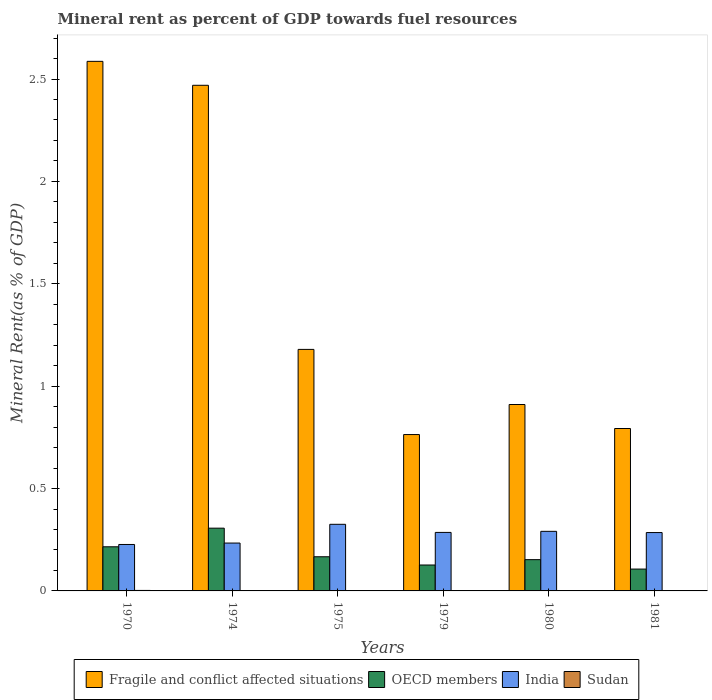How many groups of bars are there?
Make the answer very short. 6. How many bars are there on the 6th tick from the left?
Offer a very short reply. 4. How many bars are there on the 6th tick from the right?
Give a very brief answer. 4. What is the label of the 2nd group of bars from the left?
Offer a terse response. 1974. What is the mineral rent in OECD members in 1980?
Give a very brief answer. 0.15. Across all years, what is the maximum mineral rent in OECD members?
Offer a very short reply. 0.31. Across all years, what is the minimum mineral rent in India?
Keep it short and to the point. 0.23. In which year was the mineral rent in OECD members maximum?
Keep it short and to the point. 1974. In which year was the mineral rent in Sudan minimum?
Your answer should be very brief. 1975. What is the total mineral rent in OECD members in the graph?
Offer a terse response. 1.07. What is the difference between the mineral rent in Fragile and conflict affected situations in 1979 and that in 1981?
Your answer should be very brief. -0.03. What is the difference between the mineral rent in OECD members in 1981 and the mineral rent in Sudan in 1980?
Ensure brevity in your answer.  0.11. What is the average mineral rent in Fragile and conflict affected situations per year?
Make the answer very short. 1.45. In the year 1980, what is the difference between the mineral rent in OECD members and mineral rent in Sudan?
Give a very brief answer. 0.15. What is the ratio of the mineral rent in Fragile and conflict affected situations in 1974 to that in 1981?
Make the answer very short. 3.11. What is the difference between the highest and the second highest mineral rent in Sudan?
Your answer should be very brief. 0. What is the difference between the highest and the lowest mineral rent in Sudan?
Provide a succinct answer. 0. Is it the case that in every year, the sum of the mineral rent in Fragile and conflict affected situations and mineral rent in Sudan is greater than the mineral rent in OECD members?
Offer a terse response. Yes. How many years are there in the graph?
Your answer should be compact. 6. Does the graph contain grids?
Give a very brief answer. No. How many legend labels are there?
Provide a succinct answer. 4. What is the title of the graph?
Offer a terse response. Mineral rent as percent of GDP towards fuel resources. Does "Faeroe Islands" appear as one of the legend labels in the graph?
Your response must be concise. No. What is the label or title of the X-axis?
Offer a terse response. Years. What is the label or title of the Y-axis?
Keep it short and to the point. Mineral Rent(as % of GDP). What is the Mineral Rent(as % of GDP) of Fragile and conflict affected situations in 1970?
Provide a short and direct response. 2.59. What is the Mineral Rent(as % of GDP) in OECD members in 1970?
Provide a succinct answer. 0.22. What is the Mineral Rent(as % of GDP) in India in 1970?
Provide a succinct answer. 0.23. What is the Mineral Rent(as % of GDP) of Sudan in 1970?
Your answer should be very brief. 0. What is the Mineral Rent(as % of GDP) of Fragile and conflict affected situations in 1974?
Ensure brevity in your answer.  2.47. What is the Mineral Rent(as % of GDP) of OECD members in 1974?
Offer a very short reply. 0.31. What is the Mineral Rent(as % of GDP) in India in 1974?
Provide a short and direct response. 0.23. What is the Mineral Rent(as % of GDP) in Sudan in 1974?
Ensure brevity in your answer.  0. What is the Mineral Rent(as % of GDP) of Fragile and conflict affected situations in 1975?
Make the answer very short. 1.18. What is the Mineral Rent(as % of GDP) in OECD members in 1975?
Keep it short and to the point. 0.17. What is the Mineral Rent(as % of GDP) in India in 1975?
Offer a very short reply. 0.33. What is the Mineral Rent(as % of GDP) in Sudan in 1975?
Your answer should be very brief. 1.06889651710347e-5. What is the Mineral Rent(as % of GDP) of Fragile and conflict affected situations in 1979?
Your response must be concise. 0.76. What is the Mineral Rent(as % of GDP) in OECD members in 1979?
Keep it short and to the point. 0.13. What is the Mineral Rent(as % of GDP) in India in 1979?
Provide a succinct answer. 0.29. What is the Mineral Rent(as % of GDP) in Sudan in 1979?
Your response must be concise. 0. What is the Mineral Rent(as % of GDP) in Fragile and conflict affected situations in 1980?
Keep it short and to the point. 0.91. What is the Mineral Rent(as % of GDP) in OECD members in 1980?
Offer a very short reply. 0.15. What is the Mineral Rent(as % of GDP) of India in 1980?
Offer a terse response. 0.29. What is the Mineral Rent(as % of GDP) of Sudan in 1980?
Your answer should be very brief. 0. What is the Mineral Rent(as % of GDP) of Fragile and conflict affected situations in 1981?
Keep it short and to the point. 0.79. What is the Mineral Rent(as % of GDP) of OECD members in 1981?
Provide a short and direct response. 0.11. What is the Mineral Rent(as % of GDP) of India in 1981?
Make the answer very short. 0.29. What is the Mineral Rent(as % of GDP) in Sudan in 1981?
Offer a very short reply. 0. Across all years, what is the maximum Mineral Rent(as % of GDP) in Fragile and conflict affected situations?
Offer a very short reply. 2.59. Across all years, what is the maximum Mineral Rent(as % of GDP) of OECD members?
Give a very brief answer. 0.31. Across all years, what is the maximum Mineral Rent(as % of GDP) of India?
Your answer should be very brief. 0.33. Across all years, what is the maximum Mineral Rent(as % of GDP) of Sudan?
Your answer should be compact. 0. Across all years, what is the minimum Mineral Rent(as % of GDP) of Fragile and conflict affected situations?
Your answer should be compact. 0.76. Across all years, what is the minimum Mineral Rent(as % of GDP) in OECD members?
Offer a terse response. 0.11. Across all years, what is the minimum Mineral Rent(as % of GDP) in India?
Your answer should be very brief. 0.23. Across all years, what is the minimum Mineral Rent(as % of GDP) in Sudan?
Provide a short and direct response. 1.06889651710347e-5. What is the total Mineral Rent(as % of GDP) of Fragile and conflict affected situations in the graph?
Provide a short and direct response. 8.7. What is the total Mineral Rent(as % of GDP) of OECD members in the graph?
Your response must be concise. 1.07. What is the total Mineral Rent(as % of GDP) of India in the graph?
Ensure brevity in your answer.  1.65. What is the total Mineral Rent(as % of GDP) in Sudan in the graph?
Your answer should be very brief. 0. What is the difference between the Mineral Rent(as % of GDP) of Fragile and conflict affected situations in 1970 and that in 1974?
Give a very brief answer. 0.12. What is the difference between the Mineral Rent(as % of GDP) of OECD members in 1970 and that in 1974?
Your response must be concise. -0.09. What is the difference between the Mineral Rent(as % of GDP) in India in 1970 and that in 1974?
Offer a terse response. -0.01. What is the difference between the Mineral Rent(as % of GDP) of Sudan in 1970 and that in 1974?
Provide a succinct answer. 0. What is the difference between the Mineral Rent(as % of GDP) of Fragile and conflict affected situations in 1970 and that in 1975?
Make the answer very short. 1.41. What is the difference between the Mineral Rent(as % of GDP) in OECD members in 1970 and that in 1975?
Ensure brevity in your answer.  0.05. What is the difference between the Mineral Rent(as % of GDP) in India in 1970 and that in 1975?
Your answer should be very brief. -0.1. What is the difference between the Mineral Rent(as % of GDP) of Sudan in 1970 and that in 1975?
Provide a succinct answer. 0. What is the difference between the Mineral Rent(as % of GDP) in Fragile and conflict affected situations in 1970 and that in 1979?
Keep it short and to the point. 1.82. What is the difference between the Mineral Rent(as % of GDP) in OECD members in 1970 and that in 1979?
Offer a terse response. 0.09. What is the difference between the Mineral Rent(as % of GDP) of India in 1970 and that in 1979?
Ensure brevity in your answer.  -0.06. What is the difference between the Mineral Rent(as % of GDP) in Sudan in 1970 and that in 1979?
Offer a terse response. 0. What is the difference between the Mineral Rent(as % of GDP) of Fragile and conflict affected situations in 1970 and that in 1980?
Make the answer very short. 1.68. What is the difference between the Mineral Rent(as % of GDP) in OECD members in 1970 and that in 1980?
Give a very brief answer. 0.06. What is the difference between the Mineral Rent(as % of GDP) of India in 1970 and that in 1980?
Give a very brief answer. -0.06. What is the difference between the Mineral Rent(as % of GDP) in Sudan in 1970 and that in 1980?
Your answer should be very brief. 0. What is the difference between the Mineral Rent(as % of GDP) in Fragile and conflict affected situations in 1970 and that in 1981?
Ensure brevity in your answer.  1.79. What is the difference between the Mineral Rent(as % of GDP) in OECD members in 1970 and that in 1981?
Your answer should be very brief. 0.11. What is the difference between the Mineral Rent(as % of GDP) of India in 1970 and that in 1981?
Ensure brevity in your answer.  -0.06. What is the difference between the Mineral Rent(as % of GDP) of Sudan in 1970 and that in 1981?
Your response must be concise. 0. What is the difference between the Mineral Rent(as % of GDP) in Fragile and conflict affected situations in 1974 and that in 1975?
Offer a very short reply. 1.29. What is the difference between the Mineral Rent(as % of GDP) of OECD members in 1974 and that in 1975?
Offer a terse response. 0.14. What is the difference between the Mineral Rent(as % of GDP) of India in 1974 and that in 1975?
Your answer should be compact. -0.09. What is the difference between the Mineral Rent(as % of GDP) of Fragile and conflict affected situations in 1974 and that in 1979?
Keep it short and to the point. 1.71. What is the difference between the Mineral Rent(as % of GDP) of OECD members in 1974 and that in 1979?
Give a very brief answer. 0.18. What is the difference between the Mineral Rent(as % of GDP) in India in 1974 and that in 1979?
Ensure brevity in your answer.  -0.05. What is the difference between the Mineral Rent(as % of GDP) in Sudan in 1974 and that in 1979?
Ensure brevity in your answer.  -0. What is the difference between the Mineral Rent(as % of GDP) in Fragile and conflict affected situations in 1974 and that in 1980?
Offer a very short reply. 1.56. What is the difference between the Mineral Rent(as % of GDP) of OECD members in 1974 and that in 1980?
Keep it short and to the point. 0.15. What is the difference between the Mineral Rent(as % of GDP) in India in 1974 and that in 1980?
Provide a short and direct response. -0.06. What is the difference between the Mineral Rent(as % of GDP) of Sudan in 1974 and that in 1980?
Ensure brevity in your answer.  -0. What is the difference between the Mineral Rent(as % of GDP) in Fragile and conflict affected situations in 1974 and that in 1981?
Offer a terse response. 1.68. What is the difference between the Mineral Rent(as % of GDP) in OECD members in 1974 and that in 1981?
Provide a succinct answer. 0.2. What is the difference between the Mineral Rent(as % of GDP) in India in 1974 and that in 1981?
Your response must be concise. -0.05. What is the difference between the Mineral Rent(as % of GDP) in Sudan in 1974 and that in 1981?
Offer a terse response. -0. What is the difference between the Mineral Rent(as % of GDP) of Fragile and conflict affected situations in 1975 and that in 1979?
Provide a short and direct response. 0.42. What is the difference between the Mineral Rent(as % of GDP) of OECD members in 1975 and that in 1979?
Your answer should be very brief. 0.04. What is the difference between the Mineral Rent(as % of GDP) of India in 1975 and that in 1979?
Ensure brevity in your answer.  0.04. What is the difference between the Mineral Rent(as % of GDP) in Sudan in 1975 and that in 1979?
Make the answer very short. -0. What is the difference between the Mineral Rent(as % of GDP) of Fragile and conflict affected situations in 1975 and that in 1980?
Offer a very short reply. 0.27. What is the difference between the Mineral Rent(as % of GDP) in OECD members in 1975 and that in 1980?
Offer a terse response. 0.01. What is the difference between the Mineral Rent(as % of GDP) in India in 1975 and that in 1980?
Ensure brevity in your answer.  0.03. What is the difference between the Mineral Rent(as % of GDP) in Sudan in 1975 and that in 1980?
Offer a very short reply. -0. What is the difference between the Mineral Rent(as % of GDP) in Fragile and conflict affected situations in 1975 and that in 1981?
Keep it short and to the point. 0.39. What is the difference between the Mineral Rent(as % of GDP) in OECD members in 1975 and that in 1981?
Provide a short and direct response. 0.06. What is the difference between the Mineral Rent(as % of GDP) of India in 1975 and that in 1981?
Ensure brevity in your answer.  0.04. What is the difference between the Mineral Rent(as % of GDP) in Sudan in 1975 and that in 1981?
Give a very brief answer. -0. What is the difference between the Mineral Rent(as % of GDP) in Fragile and conflict affected situations in 1979 and that in 1980?
Provide a short and direct response. -0.15. What is the difference between the Mineral Rent(as % of GDP) of OECD members in 1979 and that in 1980?
Offer a very short reply. -0.03. What is the difference between the Mineral Rent(as % of GDP) in India in 1979 and that in 1980?
Provide a short and direct response. -0.01. What is the difference between the Mineral Rent(as % of GDP) of Sudan in 1979 and that in 1980?
Your answer should be compact. -0. What is the difference between the Mineral Rent(as % of GDP) of Fragile and conflict affected situations in 1979 and that in 1981?
Your answer should be very brief. -0.03. What is the difference between the Mineral Rent(as % of GDP) in OECD members in 1979 and that in 1981?
Offer a terse response. 0.02. What is the difference between the Mineral Rent(as % of GDP) of India in 1979 and that in 1981?
Give a very brief answer. 0. What is the difference between the Mineral Rent(as % of GDP) of Sudan in 1979 and that in 1981?
Ensure brevity in your answer.  -0. What is the difference between the Mineral Rent(as % of GDP) in Fragile and conflict affected situations in 1980 and that in 1981?
Make the answer very short. 0.12. What is the difference between the Mineral Rent(as % of GDP) of OECD members in 1980 and that in 1981?
Your response must be concise. 0.05. What is the difference between the Mineral Rent(as % of GDP) of India in 1980 and that in 1981?
Keep it short and to the point. 0.01. What is the difference between the Mineral Rent(as % of GDP) in Sudan in 1980 and that in 1981?
Provide a short and direct response. 0. What is the difference between the Mineral Rent(as % of GDP) of Fragile and conflict affected situations in 1970 and the Mineral Rent(as % of GDP) of OECD members in 1974?
Your answer should be compact. 2.28. What is the difference between the Mineral Rent(as % of GDP) of Fragile and conflict affected situations in 1970 and the Mineral Rent(as % of GDP) of India in 1974?
Make the answer very short. 2.35. What is the difference between the Mineral Rent(as % of GDP) in Fragile and conflict affected situations in 1970 and the Mineral Rent(as % of GDP) in Sudan in 1974?
Provide a short and direct response. 2.59. What is the difference between the Mineral Rent(as % of GDP) of OECD members in 1970 and the Mineral Rent(as % of GDP) of India in 1974?
Your answer should be compact. -0.02. What is the difference between the Mineral Rent(as % of GDP) in OECD members in 1970 and the Mineral Rent(as % of GDP) in Sudan in 1974?
Give a very brief answer. 0.22. What is the difference between the Mineral Rent(as % of GDP) in India in 1970 and the Mineral Rent(as % of GDP) in Sudan in 1974?
Keep it short and to the point. 0.23. What is the difference between the Mineral Rent(as % of GDP) in Fragile and conflict affected situations in 1970 and the Mineral Rent(as % of GDP) in OECD members in 1975?
Offer a terse response. 2.42. What is the difference between the Mineral Rent(as % of GDP) in Fragile and conflict affected situations in 1970 and the Mineral Rent(as % of GDP) in India in 1975?
Your answer should be very brief. 2.26. What is the difference between the Mineral Rent(as % of GDP) in Fragile and conflict affected situations in 1970 and the Mineral Rent(as % of GDP) in Sudan in 1975?
Provide a short and direct response. 2.59. What is the difference between the Mineral Rent(as % of GDP) in OECD members in 1970 and the Mineral Rent(as % of GDP) in India in 1975?
Ensure brevity in your answer.  -0.11. What is the difference between the Mineral Rent(as % of GDP) of OECD members in 1970 and the Mineral Rent(as % of GDP) of Sudan in 1975?
Ensure brevity in your answer.  0.22. What is the difference between the Mineral Rent(as % of GDP) in India in 1970 and the Mineral Rent(as % of GDP) in Sudan in 1975?
Offer a very short reply. 0.23. What is the difference between the Mineral Rent(as % of GDP) in Fragile and conflict affected situations in 1970 and the Mineral Rent(as % of GDP) in OECD members in 1979?
Your answer should be very brief. 2.46. What is the difference between the Mineral Rent(as % of GDP) in Fragile and conflict affected situations in 1970 and the Mineral Rent(as % of GDP) in India in 1979?
Your response must be concise. 2.3. What is the difference between the Mineral Rent(as % of GDP) in Fragile and conflict affected situations in 1970 and the Mineral Rent(as % of GDP) in Sudan in 1979?
Ensure brevity in your answer.  2.59. What is the difference between the Mineral Rent(as % of GDP) in OECD members in 1970 and the Mineral Rent(as % of GDP) in India in 1979?
Your answer should be very brief. -0.07. What is the difference between the Mineral Rent(as % of GDP) of OECD members in 1970 and the Mineral Rent(as % of GDP) of Sudan in 1979?
Your answer should be very brief. 0.22. What is the difference between the Mineral Rent(as % of GDP) in India in 1970 and the Mineral Rent(as % of GDP) in Sudan in 1979?
Offer a very short reply. 0.23. What is the difference between the Mineral Rent(as % of GDP) of Fragile and conflict affected situations in 1970 and the Mineral Rent(as % of GDP) of OECD members in 1980?
Your answer should be compact. 2.43. What is the difference between the Mineral Rent(as % of GDP) in Fragile and conflict affected situations in 1970 and the Mineral Rent(as % of GDP) in India in 1980?
Provide a short and direct response. 2.3. What is the difference between the Mineral Rent(as % of GDP) in Fragile and conflict affected situations in 1970 and the Mineral Rent(as % of GDP) in Sudan in 1980?
Provide a short and direct response. 2.58. What is the difference between the Mineral Rent(as % of GDP) of OECD members in 1970 and the Mineral Rent(as % of GDP) of India in 1980?
Offer a terse response. -0.08. What is the difference between the Mineral Rent(as % of GDP) in OECD members in 1970 and the Mineral Rent(as % of GDP) in Sudan in 1980?
Your answer should be very brief. 0.21. What is the difference between the Mineral Rent(as % of GDP) of India in 1970 and the Mineral Rent(as % of GDP) of Sudan in 1980?
Offer a terse response. 0.23. What is the difference between the Mineral Rent(as % of GDP) of Fragile and conflict affected situations in 1970 and the Mineral Rent(as % of GDP) of OECD members in 1981?
Give a very brief answer. 2.48. What is the difference between the Mineral Rent(as % of GDP) in Fragile and conflict affected situations in 1970 and the Mineral Rent(as % of GDP) in India in 1981?
Make the answer very short. 2.3. What is the difference between the Mineral Rent(as % of GDP) of Fragile and conflict affected situations in 1970 and the Mineral Rent(as % of GDP) of Sudan in 1981?
Keep it short and to the point. 2.59. What is the difference between the Mineral Rent(as % of GDP) of OECD members in 1970 and the Mineral Rent(as % of GDP) of India in 1981?
Give a very brief answer. -0.07. What is the difference between the Mineral Rent(as % of GDP) in OECD members in 1970 and the Mineral Rent(as % of GDP) in Sudan in 1981?
Offer a terse response. 0.21. What is the difference between the Mineral Rent(as % of GDP) in India in 1970 and the Mineral Rent(as % of GDP) in Sudan in 1981?
Provide a succinct answer. 0.23. What is the difference between the Mineral Rent(as % of GDP) of Fragile and conflict affected situations in 1974 and the Mineral Rent(as % of GDP) of OECD members in 1975?
Offer a very short reply. 2.3. What is the difference between the Mineral Rent(as % of GDP) in Fragile and conflict affected situations in 1974 and the Mineral Rent(as % of GDP) in India in 1975?
Provide a succinct answer. 2.14. What is the difference between the Mineral Rent(as % of GDP) in Fragile and conflict affected situations in 1974 and the Mineral Rent(as % of GDP) in Sudan in 1975?
Provide a succinct answer. 2.47. What is the difference between the Mineral Rent(as % of GDP) of OECD members in 1974 and the Mineral Rent(as % of GDP) of India in 1975?
Ensure brevity in your answer.  -0.02. What is the difference between the Mineral Rent(as % of GDP) in OECD members in 1974 and the Mineral Rent(as % of GDP) in Sudan in 1975?
Give a very brief answer. 0.31. What is the difference between the Mineral Rent(as % of GDP) of India in 1974 and the Mineral Rent(as % of GDP) of Sudan in 1975?
Your answer should be compact. 0.23. What is the difference between the Mineral Rent(as % of GDP) of Fragile and conflict affected situations in 1974 and the Mineral Rent(as % of GDP) of OECD members in 1979?
Ensure brevity in your answer.  2.34. What is the difference between the Mineral Rent(as % of GDP) in Fragile and conflict affected situations in 1974 and the Mineral Rent(as % of GDP) in India in 1979?
Your response must be concise. 2.18. What is the difference between the Mineral Rent(as % of GDP) in Fragile and conflict affected situations in 1974 and the Mineral Rent(as % of GDP) in Sudan in 1979?
Your response must be concise. 2.47. What is the difference between the Mineral Rent(as % of GDP) of OECD members in 1974 and the Mineral Rent(as % of GDP) of India in 1979?
Your answer should be very brief. 0.02. What is the difference between the Mineral Rent(as % of GDP) of OECD members in 1974 and the Mineral Rent(as % of GDP) of Sudan in 1979?
Ensure brevity in your answer.  0.31. What is the difference between the Mineral Rent(as % of GDP) of India in 1974 and the Mineral Rent(as % of GDP) of Sudan in 1979?
Ensure brevity in your answer.  0.23. What is the difference between the Mineral Rent(as % of GDP) of Fragile and conflict affected situations in 1974 and the Mineral Rent(as % of GDP) of OECD members in 1980?
Your answer should be very brief. 2.32. What is the difference between the Mineral Rent(as % of GDP) of Fragile and conflict affected situations in 1974 and the Mineral Rent(as % of GDP) of India in 1980?
Offer a very short reply. 2.18. What is the difference between the Mineral Rent(as % of GDP) in Fragile and conflict affected situations in 1974 and the Mineral Rent(as % of GDP) in Sudan in 1980?
Offer a terse response. 2.47. What is the difference between the Mineral Rent(as % of GDP) of OECD members in 1974 and the Mineral Rent(as % of GDP) of India in 1980?
Keep it short and to the point. 0.02. What is the difference between the Mineral Rent(as % of GDP) of OECD members in 1974 and the Mineral Rent(as % of GDP) of Sudan in 1980?
Your answer should be very brief. 0.31. What is the difference between the Mineral Rent(as % of GDP) in India in 1974 and the Mineral Rent(as % of GDP) in Sudan in 1980?
Make the answer very short. 0.23. What is the difference between the Mineral Rent(as % of GDP) in Fragile and conflict affected situations in 1974 and the Mineral Rent(as % of GDP) in OECD members in 1981?
Your response must be concise. 2.36. What is the difference between the Mineral Rent(as % of GDP) in Fragile and conflict affected situations in 1974 and the Mineral Rent(as % of GDP) in India in 1981?
Provide a succinct answer. 2.18. What is the difference between the Mineral Rent(as % of GDP) in Fragile and conflict affected situations in 1974 and the Mineral Rent(as % of GDP) in Sudan in 1981?
Your response must be concise. 2.47. What is the difference between the Mineral Rent(as % of GDP) in OECD members in 1974 and the Mineral Rent(as % of GDP) in India in 1981?
Your answer should be compact. 0.02. What is the difference between the Mineral Rent(as % of GDP) of OECD members in 1974 and the Mineral Rent(as % of GDP) of Sudan in 1981?
Keep it short and to the point. 0.31. What is the difference between the Mineral Rent(as % of GDP) in India in 1974 and the Mineral Rent(as % of GDP) in Sudan in 1981?
Make the answer very short. 0.23. What is the difference between the Mineral Rent(as % of GDP) in Fragile and conflict affected situations in 1975 and the Mineral Rent(as % of GDP) in OECD members in 1979?
Give a very brief answer. 1.05. What is the difference between the Mineral Rent(as % of GDP) of Fragile and conflict affected situations in 1975 and the Mineral Rent(as % of GDP) of India in 1979?
Your answer should be compact. 0.89. What is the difference between the Mineral Rent(as % of GDP) of Fragile and conflict affected situations in 1975 and the Mineral Rent(as % of GDP) of Sudan in 1979?
Make the answer very short. 1.18. What is the difference between the Mineral Rent(as % of GDP) of OECD members in 1975 and the Mineral Rent(as % of GDP) of India in 1979?
Your answer should be very brief. -0.12. What is the difference between the Mineral Rent(as % of GDP) of OECD members in 1975 and the Mineral Rent(as % of GDP) of Sudan in 1979?
Offer a terse response. 0.17. What is the difference between the Mineral Rent(as % of GDP) in India in 1975 and the Mineral Rent(as % of GDP) in Sudan in 1979?
Offer a very short reply. 0.33. What is the difference between the Mineral Rent(as % of GDP) in Fragile and conflict affected situations in 1975 and the Mineral Rent(as % of GDP) in OECD members in 1980?
Provide a succinct answer. 1.03. What is the difference between the Mineral Rent(as % of GDP) of Fragile and conflict affected situations in 1975 and the Mineral Rent(as % of GDP) of India in 1980?
Your answer should be very brief. 0.89. What is the difference between the Mineral Rent(as % of GDP) in Fragile and conflict affected situations in 1975 and the Mineral Rent(as % of GDP) in Sudan in 1980?
Offer a terse response. 1.18. What is the difference between the Mineral Rent(as % of GDP) in OECD members in 1975 and the Mineral Rent(as % of GDP) in India in 1980?
Provide a succinct answer. -0.12. What is the difference between the Mineral Rent(as % of GDP) in OECD members in 1975 and the Mineral Rent(as % of GDP) in Sudan in 1980?
Give a very brief answer. 0.17. What is the difference between the Mineral Rent(as % of GDP) in India in 1975 and the Mineral Rent(as % of GDP) in Sudan in 1980?
Give a very brief answer. 0.32. What is the difference between the Mineral Rent(as % of GDP) of Fragile and conflict affected situations in 1975 and the Mineral Rent(as % of GDP) of OECD members in 1981?
Make the answer very short. 1.07. What is the difference between the Mineral Rent(as % of GDP) in Fragile and conflict affected situations in 1975 and the Mineral Rent(as % of GDP) in India in 1981?
Ensure brevity in your answer.  0.89. What is the difference between the Mineral Rent(as % of GDP) of Fragile and conflict affected situations in 1975 and the Mineral Rent(as % of GDP) of Sudan in 1981?
Your answer should be compact. 1.18. What is the difference between the Mineral Rent(as % of GDP) of OECD members in 1975 and the Mineral Rent(as % of GDP) of India in 1981?
Give a very brief answer. -0.12. What is the difference between the Mineral Rent(as % of GDP) in OECD members in 1975 and the Mineral Rent(as % of GDP) in Sudan in 1981?
Your answer should be very brief. 0.17. What is the difference between the Mineral Rent(as % of GDP) of India in 1975 and the Mineral Rent(as % of GDP) of Sudan in 1981?
Keep it short and to the point. 0.32. What is the difference between the Mineral Rent(as % of GDP) in Fragile and conflict affected situations in 1979 and the Mineral Rent(as % of GDP) in OECD members in 1980?
Ensure brevity in your answer.  0.61. What is the difference between the Mineral Rent(as % of GDP) in Fragile and conflict affected situations in 1979 and the Mineral Rent(as % of GDP) in India in 1980?
Provide a succinct answer. 0.47. What is the difference between the Mineral Rent(as % of GDP) of Fragile and conflict affected situations in 1979 and the Mineral Rent(as % of GDP) of Sudan in 1980?
Your response must be concise. 0.76. What is the difference between the Mineral Rent(as % of GDP) in OECD members in 1979 and the Mineral Rent(as % of GDP) in India in 1980?
Offer a terse response. -0.16. What is the difference between the Mineral Rent(as % of GDP) in OECD members in 1979 and the Mineral Rent(as % of GDP) in Sudan in 1980?
Make the answer very short. 0.13. What is the difference between the Mineral Rent(as % of GDP) in India in 1979 and the Mineral Rent(as % of GDP) in Sudan in 1980?
Ensure brevity in your answer.  0.28. What is the difference between the Mineral Rent(as % of GDP) in Fragile and conflict affected situations in 1979 and the Mineral Rent(as % of GDP) in OECD members in 1981?
Give a very brief answer. 0.66. What is the difference between the Mineral Rent(as % of GDP) of Fragile and conflict affected situations in 1979 and the Mineral Rent(as % of GDP) of India in 1981?
Your answer should be very brief. 0.48. What is the difference between the Mineral Rent(as % of GDP) in Fragile and conflict affected situations in 1979 and the Mineral Rent(as % of GDP) in Sudan in 1981?
Your answer should be very brief. 0.76. What is the difference between the Mineral Rent(as % of GDP) of OECD members in 1979 and the Mineral Rent(as % of GDP) of India in 1981?
Offer a very short reply. -0.16. What is the difference between the Mineral Rent(as % of GDP) in OECD members in 1979 and the Mineral Rent(as % of GDP) in Sudan in 1981?
Offer a very short reply. 0.13. What is the difference between the Mineral Rent(as % of GDP) of India in 1979 and the Mineral Rent(as % of GDP) of Sudan in 1981?
Offer a terse response. 0.29. What is the difference between the Mineral Rent(as % of GDP) in Fragile and conflict affected situations in 1980 and the Mineral Rent(as % of GDP) in OECD members in 1981?
Make the answer very short. 0.8. What is the difference between the Mineral Rent(as % of GDP) in Fragile and conflict affected situations in 1980 and the Mineral Rent(as % of GDP) in India in 1981?
Offer a very short reply. 0.63. What is the difference between the Mineral Rent(as % of GDP) in Fragile and conflict affected situations in 1980 and the Mineral Rent(as % of GDP) in Sudan in 1981?
Provide a short and direct response. 0.91. What is the difference between the Mineral Rent(as % of GDP) of OECD members in 1980 and the Mineral Rent(as % of GDP) of India in 1981?
Your answer should be very brief. -0.13. What is the difference between the Mineral Rent(as % of GDP) of OECD members in 1980 and the Mineral Rent(as % of GDP) of Sudan in 1981?
Your response must be concise. 0.15. What is the difference between the Mineral Rent(as % of GDP) in India in 1980 and the Mineral Rent(as % of GDP) in Sudan in 1981?
Make the answer very short. 0.29. What is the average Mineral Rent(as % of GDP) of Fragile and conflict affected situations per year?
Give a very brief answer. 1.45. What is the average Mineral Rent(as % of GDP) of OECD members per year?
Give a very brief answer. 0.18. What is the average Mineral Rent(as % of GDP) of India per year?
Your answer should be very brief. 0.27. What is the average Mineral Rent(as % of GDP) of Sudan per year?
Give a very brief answer. 0. In the year 1970, what is the difference between the Mineral Rent(as % of GDP) in Fragile and conflict affected situations and Mineral Rent(as % of GDP) in OECD members?
Your answer should be compact. 2.37. In the year 1970, what is the difference between the Mineral Rent(as % of GDP) of Fragile and conflict affected situations and Mineral Rent(as % of GDP) of India?
Offer a terse response. 2.36. In the year 1970, what is the difference between the Mineral Rent(as % of GDP) in Fragile and conflict affected situations and Mineral Rent(as % of GDP) in Sudan?
Your answer should be compact. 2.58. In the year 1970, what is the difference between the Mineral Rent(as % of GDP) of OECD members and Mineral Rent(as % of GDP) of India?
Ensure brevity in your answer.  -0.01. In the year 1970, what is the difference between the Mineral Rent(as % of GDP) in OECD members and Mineral Rent(as % of GDP) in Sudan?
Offer a terse response. 0.21. In the year 1970, what is the difference between the Mineral Rent(as % of GDP) in India and Mineral Rent(as % of GDP) in Sudan?
Offer a very short reply. 0.22. In the year 1974, what is the difference between the Mineral Rent(as % of GDP) of Fragile and conflict affected situations and Mineral Rent(as % of GDP) of OECD members?
Your answer should be compact. 2.16. In the year 1974, what is the difference between the Mineral Rent(as % of GDP) of Fragile and conflict affected situations and Mineral Rent(as % of GDP) of India?
Your answer should be compact. 2.24. In the year 1974, what is the difference between the Mineral Rent(as % of GDP) in Fragile and conflict affected situations and Mineral Rent(as % of GDP) in Sudan?
Give a very brief answer. 2.47. In the year 1974, what is the difference between the Mineral Rent(as % of GDP) of OECD members and Mineral Rent(as % of GDP) of India?
Keep it short and to the point. 0.07. In the year 1974, what is the difference between the Mineral Rent(as % of GDP) of OECD members and Mineral Rent(as % of GDP) of Sudan?
Make the answer very short. 0.31. In the year 1974, what is the difference between the Mineral Rent(as % of GDP) of India and Mineral Rent(as % of GDP) of Sudan?
Your response must be concise. 0.23. In the year 1975, what is the difference between the Mineral Rent(as % of GDP) in Fragile and conflict affected situations and Mineral Rent(as % of GDP) in OECD members?
Provide a succinct answer. 1.01. In the year 1975, what is the difference between the Mineral Rent(as % of GDP) in Fragile and conflict affected situations and Mineral Rent(as % of GDP) in India?
Ensure brevity in your answer.  0.85. In the year 1975, what is the difference between the Mineral Rent(as % of GDP) of Fragile and conflict affected situations and Mineral Rent(as % of GDP) of Sudan?
Ensure brevity in your answer.  1.18. In the year 1975, what is the difference between the Mineral Rent(as % of GDP) in OECD members and Mineral Rent(as % of GDP) in India?
Provide a succinct answer. -0.16. In the year 1975, what is the difference between the Mineral Rent(as % of GDP) of OECD members and Mineral Rent(as % of GDP) of Sudan?
Keep it short and to the point. 0.17. In the year 1975, what is the difference between the Mineral Rent(as % of GDP) in India and Mineral Rent(as % of GDP) in Sudan?
Keep it short and to the point. 0.33. In the year 1979, what is the difference between the Mineral Rent(as % of GDP) of Fragile and conflict affected situations and Mineral Rent(as % of GDP) of OECD members?
Offer a terse response. 0.64. In the year 1979, what is the difference between the Mineral Rent(as % of GDP) of Fragile and conflict affected situations and Mineral Rent(as % of GDP) of India?
Ensure brevity in your answer.  0.48. In the year 1979, what is the difference between the Mineral Rent(as % of GDP) in Fragile and conflict affected situations and Mineral Rent(as % of GDP) in Sudan?
Provide a succinct answer. 0.76. In the year 1979, what is the difference between the Mineral Rent(as % of GDP) in OECD members and Mineral Rent(as % of GDP) in India?
Keep it short and to the point. -0.16. In the year 1979, what is the difference between the Mineral Rent(as % of GDP) in OECD members and Mineral Rent(as % of GDP) in Sudan?
Give a very brief answer. 0.13. In the year 1979, what is the difference between the Mineral Rent(as % of GDP) in India and Mineral Rent(as % of GDP) in Sudan?
Your answer should be compact. 0.29. In the year 1980, what is the difference between the Mineral Rent(as % of GDP) of Fragile and conflict affected situations and Mineral Rent(as % of GDP) of OECD members?
Offer a terse response. 0.76. In the year 1980, what is the difference between the Mineral Rent(as % of GDP) of Fragile and conflict affected situations and Mineral Rent(as % of GDP) of India?
Your response must be concise. 0.62. In the year 1980, what is the difference between the Mineral Rent(as % of GDP) of Fragile and conflict affected situations and Mineral Rent(as % of GDP) of Sudan?
Your answer should be very brief. 0.91. In the year 1980, what is the difference between the Mineral Rent(as % of GDP) of OECD members and Mineral Rent(as % of GDP) of India?
Offer a terse response. -0.14. In the year 1980, what is the difference between the Mineral Rent(as % of GDP) in OECD members and Mineral Rent(as % of GDP) in Sudan?
Provide a short and direct response. 0.15. In the year 1980, what is the difference between the Mineral Rent(as % of GDP) in India and Mineral Rent(as % of GDP) in Sudan?
Your answer should be compact. 0.29. In the year 1981, what is the difference between the Mineral Rent(as % of GDP) of Fragile and conflict affected situations and Mineral Rent(as % of GDP) of OECD members?
Provide a succinct answer. 0.69. In the year 1981, what is the difference between the Mineral Rent(as % of GDP) of Fragile and conflict affected situations and Mineral Rent(as % of GDP) of India?
Offer a terse response. 0.51. In the year 1981, what is the difference between the Mineral Rent(as % of GDP) in Fragile and conflict affected situations and Mineral Rent(as % of GDP) in Sudan?
Your answer should be compact. 0.79. In the year 1981, what is the difference between the Mineral Rent(as % of GDP) of OECD members and Mineral Rent(as % of GDP) of India?
Your answer should be very brief. -0.18. In the year 1981, what is the difference between the Mineral Rent(as % of GDP) of OECD members and Mineral Rent(as % of GDP) of Sudan?
Ensure brevity in your answer.  0.11. In the year 1981, what is the difference between the Mineral Rent(as % of GDP) of India and Mineral Rent(as % of GDP) of Sudan?
Provide a succinct answer. 0.28. What is the ratio of the Mineral Rent(as % of GDP) of Fragile and conflict affected situations in 1970 to that in 1974?
Your answer should be compact. 1.05. What is the ratio of the Mineral Rent(as % of GDP) in OECD members in 1970 to that in 1974?
Your response must be concise. 0.7. What is the ratio of the Mineral Rent(as % of GDP) in India in 1970 to that in 1974?
Your answer should be compact. 0.97. What is the ratio of the Mineral Rent(as % of GDP) in Sudan in 1970 to that in 1974?
Ensure brevity in your answer.  18.57. What is the ratio of the Mineral Rent(as % of GDP) in Fragile and conflict affected situations in 1970 to that in 1975?
Ensure brevity in your answer.  2.19. What is the ratio of the Mineral Rent(as % of GDP) in OECD members in 1970 to that in 1975?
Provide a short and direct response. 1.29. What is the ratio of the Mineral Rent(as % of GDP) of India in 1970 to that in 1975?
Give a very brief answer. 0.7. What is the ratio of the Mineral Rent(as % of GDP) in Sudan in 1970 to that in 1975?
Your answer should be compact. 223.77. What is the ratio of the Mineral Rent(as % of GDP) of Fragile and conflict affected situations in 1970 to that in 1979?
Your answer should be compact. 3.39. What is the ratio of the Mineral Rent(as % of GDP) in OECD members in 1970 to that in 1979?
Offer a terse response. 1.7. What is the ratio of the Mineral Rent(as % of GDP) in India in 1970 to that in 1979?
Your answer should be very brief. 0.79. What is the ratio of the Mineral Rent(as % of GDP) of Sudan in 1970 to that in 1979?
Keep it short and to the point. 8.62. What is the ratio of the Mineral Rent(as % of GDP) of Fragile and conflict affected situations in 1970 to that in 1980?
Your answer should be very brief. 2.84. What is the ratio of the Mineral Rent(as % of GDP) of OECD members in 1970 to that in 1980?
Offer a very short reply. 1.41. What is the ratio of the Mineral Rent(as % of GDP) of India in 1970 to that in 1980?
Keep it short and to the point. 0.78. What is the ratio of the Mineral Rent(as % of GDP) in Sudan in 1970 to that in 1980?
Keep it short and to the point. 1.75. What is the ratio of the Mineral Rent(as % of GDP) of Fragile and conflict affected situations in 1970 to that in 1981?
Your answer should be very brief. 3.26. What is the ratio of the Mineral Rent(as % of GDP) of OECD members in 1970 to that in 1981?
Your answer should be very brief. 2.02. What is the ratio of the Mineral Rent(as % of GDP) of India in 1970 to that in 1981?
Provide a short and direct response. 0.8. What is the ratio of the Mineral Rent(as % of GDP) in Sudan in 1970 to that in 1981?
Your answer should be very brief. 3.74. What is the ratio of the Mineral Rent(as % of GDP) of Fragile and conflict affected situations in 1974 to that in 1975?
Provide a succinct answer. 2.09. What is the ratio of the Mineral Rent(as % of GDP) of OECD members in 1974 to that in 1975?
Keep it short and to the point. 1.84. What is the ratio of the Mineral Rent(as % of GDP) in India in 1974 to that in 1975?
Your answer should be very brief. 0.72. What is the ratio of the Mineral Rent(as % of GDP) of Sudan in 1974 to that in 1975?
Keep it short and to the point. 12.05. What is the ratio of the Mineral Rent(as % of GDP) of Fragile and conflict affected situations in 1974 to that in 1979?
Your answer should be very brief. 3.23. What is the ratio of the Mineral Rent(as % of GDP) of OECD members in 1974 to that in 1979?
Ensure brevity in your answer.  2.42. What is the ratio of the Mineral Rent(as % of GDP) of India in 1974 to that in 1979?
Ensure brevity in your answer.  0.82. What is the ratio of the Mineral Rent(as % of GDP) in Sudan in 1974 to that in 1979?
Your response must be concise. 0.46. What is the ratio of the Mineral Rent(as % of GDP) of Fragile and conflict affected situations in 1974 to that in 1980?
Your response must be concise. 2.71. What is the ratio of the Mineral Rent(as % of GDP) of OECD members in 1974 to that in 1980?
Keep it short and to the point. 2.01. What is the ratio of the Mineral Rent(as % of GDP) in India in 1974 to that in 1980?
Offer a very short reply. 0.8. What is the ratio of the Mineral Rent(as % of GDP) of Sudan in 1974 to that in 1980?
Provide a succinct answer. 0.09. What is the ratio of the Mineral Rent(as % of GDP) of Fragile and conflict affected situations in 1974 to that in 1981?
Provide a short and direct response. 3.11. What is the ratio of the Mineral Rent(as % of GDP) in OECD members in 1974 to that in 1981?
Keep it short and to the point. 2.87. What is the ratio of the Mineral Rent(as % of GDP) of India in 1974 to that in 1981?
Your response must be concise. 0.82. What is the ratio of the Mineral Rent(as % of GDP) of Sudan in 1974 to that in 1981?
Your response must be concise. 0.2. What is the ratio of the Mineral Rent(as % of GDP) of Fragile and conflict affected situations in 1975 to that in 1979?
Offer a very short reply. 1.54. What is the ratio of the Mineral Rent(as % of GDP) in OECD members in 1975 to that in 1979?
Give a very brief answer. 1.32. What is the ratio of the Mineral Rent(as % of GDP) in India in 1975 to that in 1979?
Offer a very short reply. 1.14. What is the ratio of the Mineral Rent(as % of GDP) in Sudan in 1975 to that in 1979?
Keep it short and to the point. 0.04. What is the ratio of the Mineral Rent(as % of GDP) in Fragile and conflict affected situations in 1975 to that in 1980?
Make the answer very short. 1.3. What is the ratio of the Mineral Rent(as % of GDP) of OECD members in 1975 to that in 1980?
Offer a terse response. 1.09. What is the ratio of the Mineral Rent(as % of GDP) in India in 1975 to that in 1980?
Your response must be concise. 1.12. What is the ratio of the Mineral Rent(as % of GDP) of Sudan in 1975 to that in 1980?
Your answer should be compact. 0.01. What is the ratio of the Mineral Rent(as % of GDP) in Fragile and conflict affected situations in 1975 to that in 1981?
Provide a succinct answer. 1.49. What is the ratio of the Mineral Rent(as % of GDP) in OECD members in 1975 to that in 1981?
Your answer should be compact. 1.56. What is the ratio of the Mineral Rent(as % of GDP) in India in 1975 to that in 1981?
Offer a very short reply. 1.14. What is the ratio of the Mineral Rent(as % of GDP) in Sudan in 1975 to that in 1981?
Keep it short and to the point. 0.02. What is the ratio of the Mineral Rent(as % of GDP) in Fragile and conflict affected situations in 1979 to that in 1980?
Offer a terse response. 0.84. What is the ratio of the Mineral Rent(as % of GDP) in OECD members in 1979 to that in 1980?
Ensure brevity in your answer.  0.83. What is the ratio of the Mineral Rent(as % of GDP) in India in 1979 to that in 1980?
Your response must be concise. 0.98. What is the ratio of the Mineral Rent(as % of GDP) of Sudan in 1979 to that in 1980?
Ensure brevity in your answer.  0.2. What is the ratio of the Mineral Rent(as % of GDP) in Fragile and conflict affected situations in 1979 to that in 1981?
Ensure brevity in your answer.  0.96. What is the ratio of the Mineral Rent(as % of GDP) of OECD members in 1979 to that in 1981?
Ensure brevity in your answer.  1.19. What is the ratio of the Mineral Rent(as % of GDP) in Sudan in 1979 to that in 1981?
Offer a very short reply. 0.43. What is the ratio of the Mineral Rent(as % of GDP) of Fragile and conflict affected situations in 1980 to that in 1981?
Give a very brief answer. 1.15. What is the ratio of the Mineral Rent(as % of GDP) in OECD members in 1980 to that in 1981?
Your answer should be very brief. 1.43. What is the ratio of the Mineral Rent(as % of GDP) in India in 1980 to that in 1981?
Keep it short and to the point. 1.02. What is the ratio of the Mineral Rent(as % of GDP) of Sudan in 1980 to that in 1981?
Make the answer very short. 2.13. What is the difference between the highest and the second highest Mineral Rent(as % of GDP) in Fragile and conflict affected situations?
Your answer should be compact. 0.12. What is the difference between the highest and the second highest Mineral Rent(as % of GDP) of OECD members?
Your response must be concise. 0.09. What is the difference between the highest and the second highest Mineral Rent(as % of GDP) of India?
Ensure brevity in your answer.  0.03. What is the difference between the highest and the lowest Mineral Rent(as % of GDP) in Fragile and conflict affected situations?
Your answer should be compact. 1.82. What is the difference between the highest and the lowest Mineral Rent(as % of GDP) in OECD members?
Provide a succinct answer. 0.2. What is the difference between the highest and the lowest Mineral Rent(as % of GDP) in India?
Your answer should be compact. 0.1. What is the difference between the highest and the lowest Mineral Rent(as % of GDP) in Sudan?
Offer a very short reply. 0. 